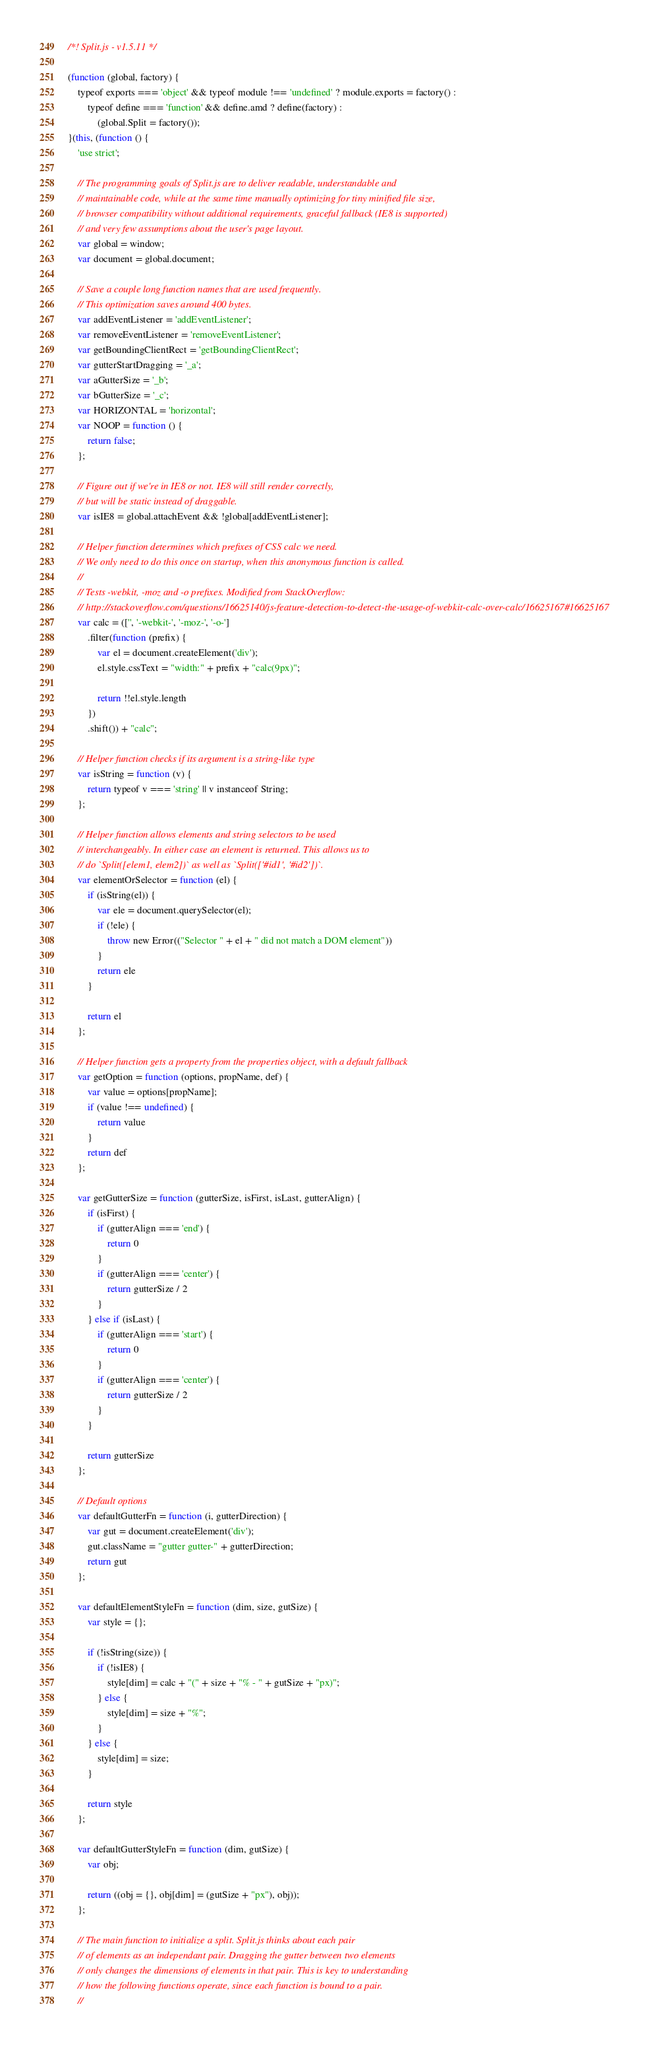<code> <loc_0><loc_0><loc_500><loc_500><_JavaScript_>/*! Split.js - v1.5.11 */

(function (global, factory) {
    typeof exports === 'object' && typeof module !== 'undefined' ? module.exports = factory() :
        typeof define === 'function' && define.amd ? define(factory) :
            (global.Split = factory());
}(this, (function () {
    'use strict';

    // The programming goals of Split.js are to deliver readable, understandable and
    // maintainable code, while at the same time manually optimizing for tiny minified file size,
    // browser compatibility without additional requirements, graceful fallback (IE8 is supported)
    // and very few assumptions about the user's page layout.
    var global = window;
    var document = global.document;

    // Save a couple long function names that are used frequently.
    // This optimization saves around 400 bytes.
    var addEventListener = 'addEventListener';
    var removeEventListener = 'removeEventListener';
    var getBoundingClientRect = 'getBoundingClientRect';
    var gutterStartDragging = '_a';
    var aGutterSize = '_b';
    var bGutterSize = '_c';
    var HORIZONTAL = 'horizontal';
    var NOOP = function () {
        return false;
    };

    // Figure out if we're in IE8 or not. IE8 will still render correctly,
    // but will be static instead of draggable.
    var isIE8 = global.attachEvent && !global[addEventListener];

    // Helper function determines which prefixes of CSS calc we need.
    // We only need to do this once on startup, when this anonymous function is called.
    //
    // Tests -webkit, -moz and -o prefixes. Modified from StackOverflow:
    // http://stackoverflow.com/questions/16625140/js-feature-detection-to-detect-the-usage-of-webkit-calc-over-calc/16625167#16625167
    var calc = (['', '-webkit-', '-moz-', '-o-']
        .filter(function (prefix) {
            var el = document.createElement('div');
            el.style.cssText = "width:" + prefix + "calc(9px)";

            return !!el.style.length
        })
        .shift()) + "calc";

    // Helper function checks if its argument is a string-like type
    var isString = function (v) {
        return typeof v === 'string' || v instanceof String;
    };

    // Helper function allows elements and string selectors to be used
    // interchangeably. In either case an element is returned. This allows us to
    // do `Split([elem1, elem2])` as well as `Split(['#id1', '#id2'])`.
    var elementOrSelector = function (el) {
        if (isString(el)) {
            var ele = document.querySelector(el);
            if (!ele) {
                throw new Error(("Selector " + el + " did not match a DOM element"))
            }
            return ele
        }

        return el
    };

    // Helper function gets a property from the properties object, with a default fallback
    var getOption = function (options, propName, def) {
        var value = options[propName];
        if (value !== undefined) {
            return value
        }
        return def
    };

    var getGutterSize = function (gutterSize, isFirst, isLast, gutterAlign) {
        if (isFirst) {
            if (gutterAlign === 'end') {
                return 0
            }
            if (gutterAlign === 'center') {
                return gutterSize / 2
            }
        } else if (isLast) {
            if (gutterAlign === 'start') {
                return 0
            }
            if (gutterAlign === 'center') {
                return gutterSize / 2
            }
        }

        return gutterSize
    };

    // Default options
    var defaultGutterFn = function (i, gutterDirection) {
        var gut = document.createElement('div');
        gut.className = "gutter gutter-" + gutterDirection;
        return gut
    };

    var defaultElementStyleFn = function (dim, size, gutSize) {
        var style = {};

        if (!isString(size)) {
            if (!isIE8) {
                style[dim] = calc + "(" + size + "% - " + gutSize + "px)";
            } else {
                style[dim] = size + "%";
            }
        } else {
            style[dim] = size;
        }

        return style
    };

    var defaultGutterStyleFn = function (dim, gutSize) {
        var obj;

        return ((obj = {}, obj[dim] = (gutSize + "px"), obj));
    };

    // The main function to initialize a split. Split.js thinks about each pair
    // of elements as an independant pair. Dragging the gutter between two elements
    // only changes the dimensions of elements in that pair. This is key to understanding
    // how the following functions operate, since each function is bound to a pair.
    //</code> 